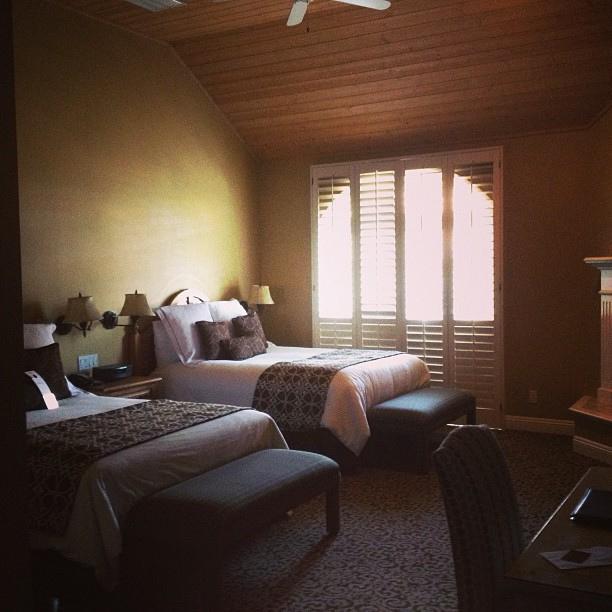Is there enough sunlight for the room?
Be succinct. Yes. Is the floor reflective?
Concise answer only. No. Are the lights on?
Short answer required. No. What color are the walls?
Give a very brief answer. Beige. What is covering the window?
Give a very brief answer. Blinds. How many lamps are in the room?
Short answer required. 3. How many windows are there?
Concise answer only. 1. What room is this?
Be succinct. Bedroom. How many lamps are in the picture?
Be succinct. 3. How many people would be able to sleep in this bed?
Answer briefly. 2. What kind of chair is in the lower right hand corner?
Write a very short answer. Desk chair. Is there a fan in the room?
Quick response, please. Yes. How many beds are in the picture?
Write a very short answer. 2. 